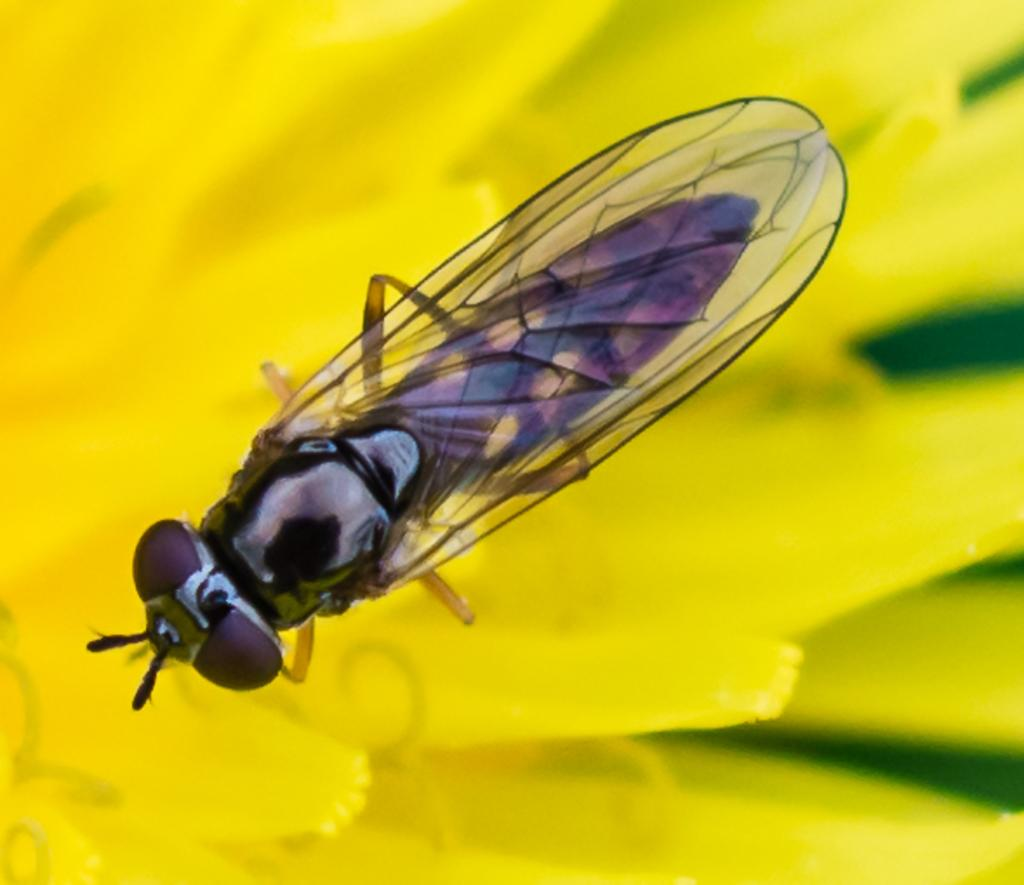What type of creature is in the image? There is an insect in the image. What feature does the insect have? The insect has wings. Where is the insect located in the image? The insect is on a yellow flower. How would you describe the background of the image? The background of the image is blurred. What advice does the insect give to the cherry in the image? There is no cherry present in the image, and insects do not give advice. 